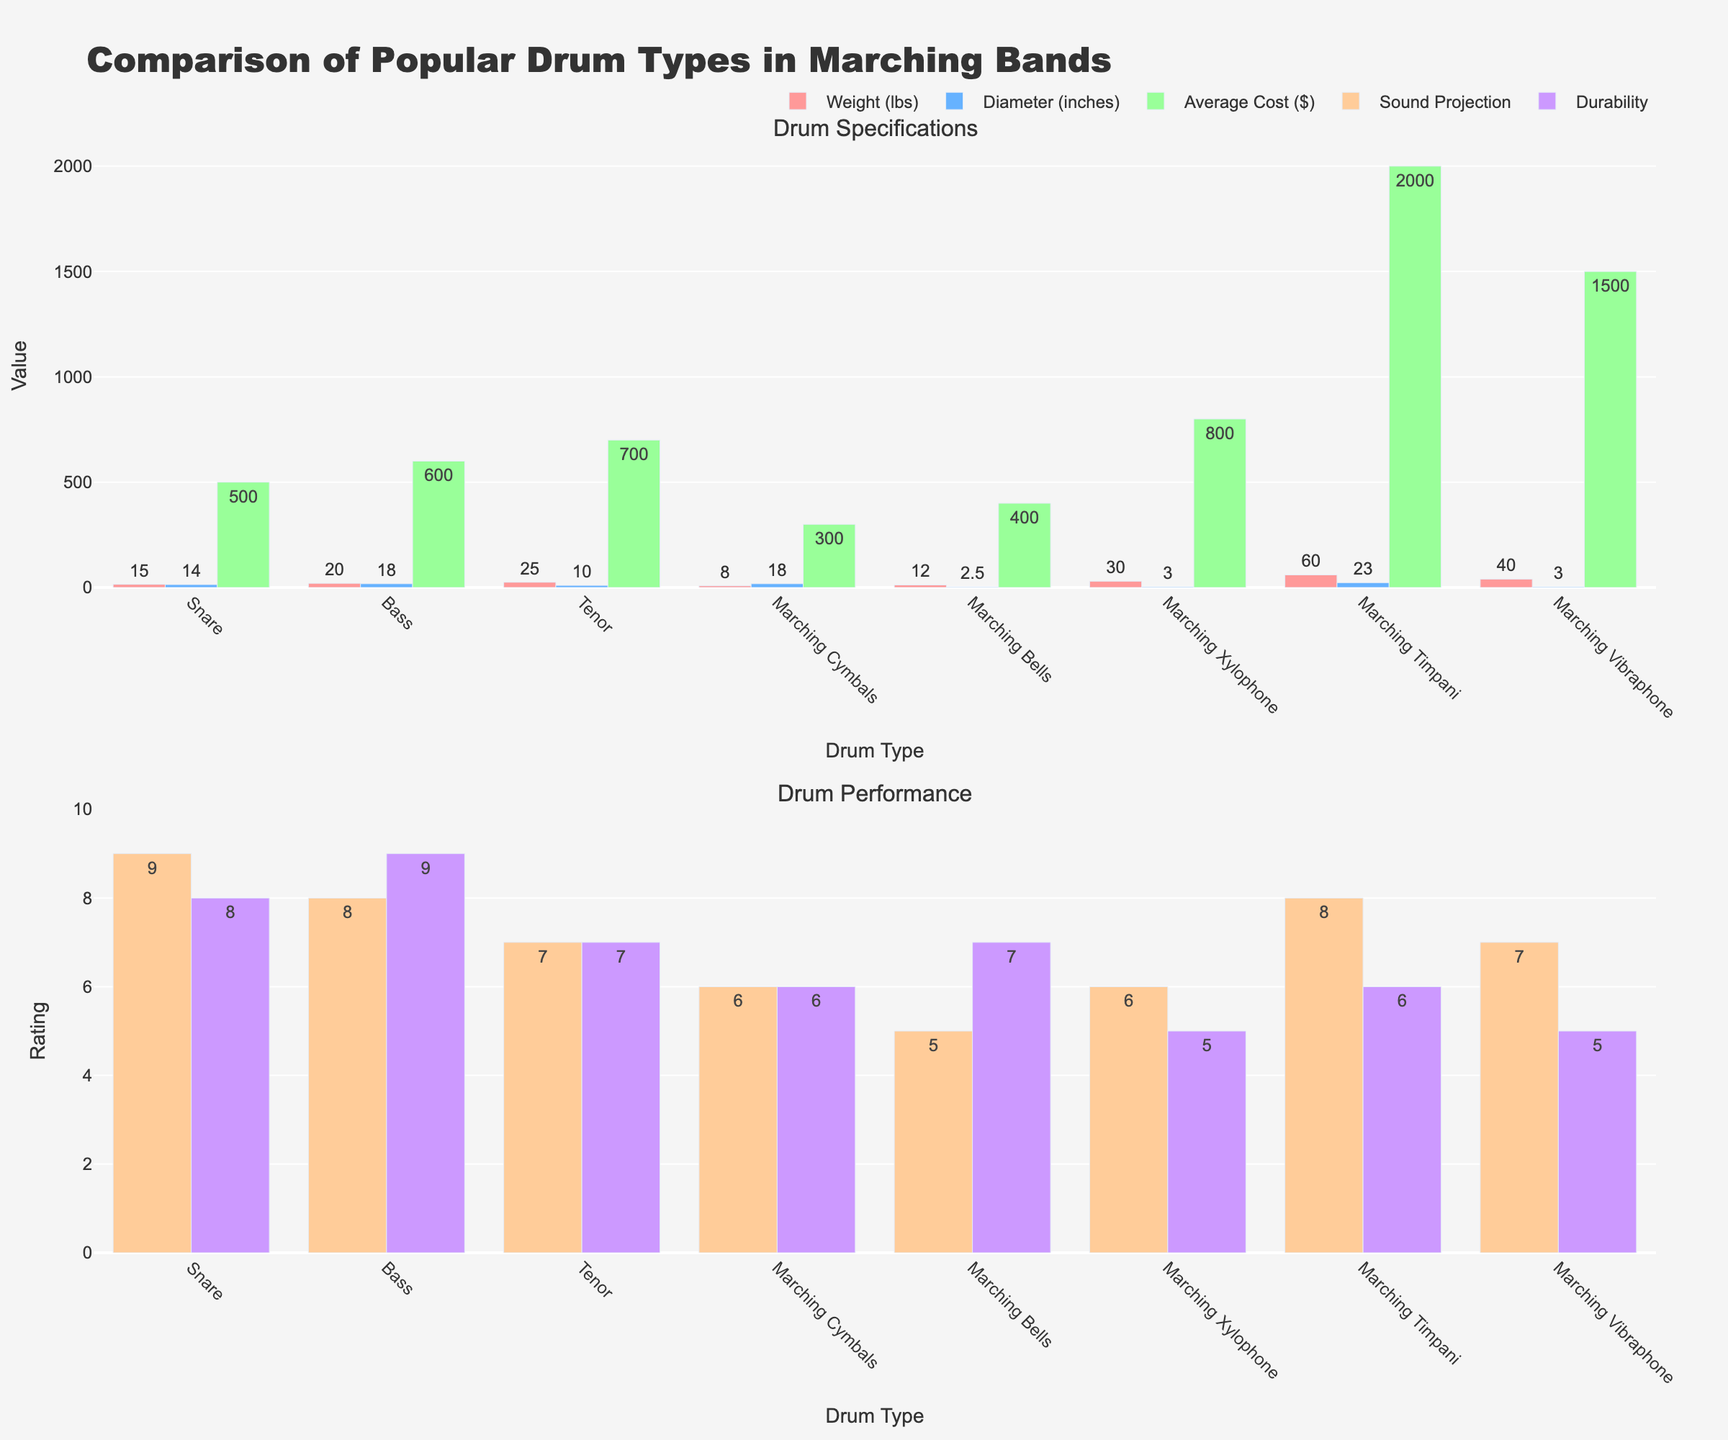Which drum type has the highest average cost? By looking at the bar height in the "Average Cost ($)" trace, we see that the Marching Timpani has the highest bar, indicating the highest cost.
Answer: Marching Timpani Which drum types have a sound projection rating of 8? Checking the "Sound Projection (1-10)" trace, we find two bars at the height of 8: Bass and Marching Timpani.
Answer: Bass, Marching Timpani What is the difference in weight between the Snare drum and the Tenor drum? From the "Weight (lbs)" trace, we see that the Snare drum weighs 15 lbs and the Tenor drum weighs 25 lbs. The difference is 25 - 15 = 10 lbs.
Answer: 10 lbs Which drum type is both the heaviest and has the lowest durability rating? From the "Weight (lbs)" and "Durability (1-10)" traces, the heaviest drum is the Marching Timpani with a weight of 60 lbs and it has a durability rating of 6, which is among the lowest.
Answer: Marching Timpani How much more expensive is the Marching Vibraphone than the Snare drum? Referencing the "Average Cost ($)" trace: 
- Marching Vibraphone costs $1500,
- Snare drum costs $500,
The difference is $1500 - $500 = $1000.
Answer: $1000 Which drum type has the smallest diameter, and what is its diameter? Based on the "Diameter (inches)" trace, Marching Bells have the smallest diameter at 2.5 inches.
Answer: Marching Bells, 2.5 inches What is the average weight of the Bass, Snare, and Tenor drums? The weights for Bass, Snare, and Tenor drums are 20 lbs, 15 lbs, and 25 lbs respectively. The average weight is (20 + 15 + 25) / 3 = 60 / 3 = 20 lbs.
Answer: 20 lbs Which drum type has both moderate durability (rating of 6-8) and low sound projection (rating of 6 or below)? From the "Durability (1-10)" and "Sound Projection (1-10)" traces, Marching Cymbals fit the criteria with durability 6 and sound projection 6.
Answer: Marching Cymbals 